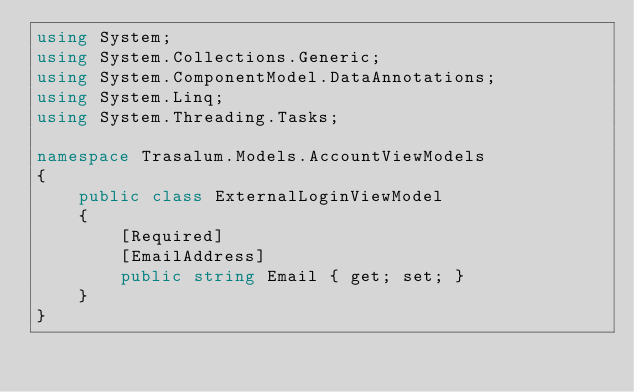<code> <loc_0><loc_0><loc_500><loc_500><_C#_>using System;
using System.Collections.Generic;
using System.ComponentModel.DataAnnotations;
using System.Linq;
using System.Threading.Tasks;

namespace Trasalum.Models.AccountViewModels
{
    public class ExternalLoginViewModel
    {
        [Required]
        [EmailAddress]
        public string Email { get; set; }
    }
}
</code> 